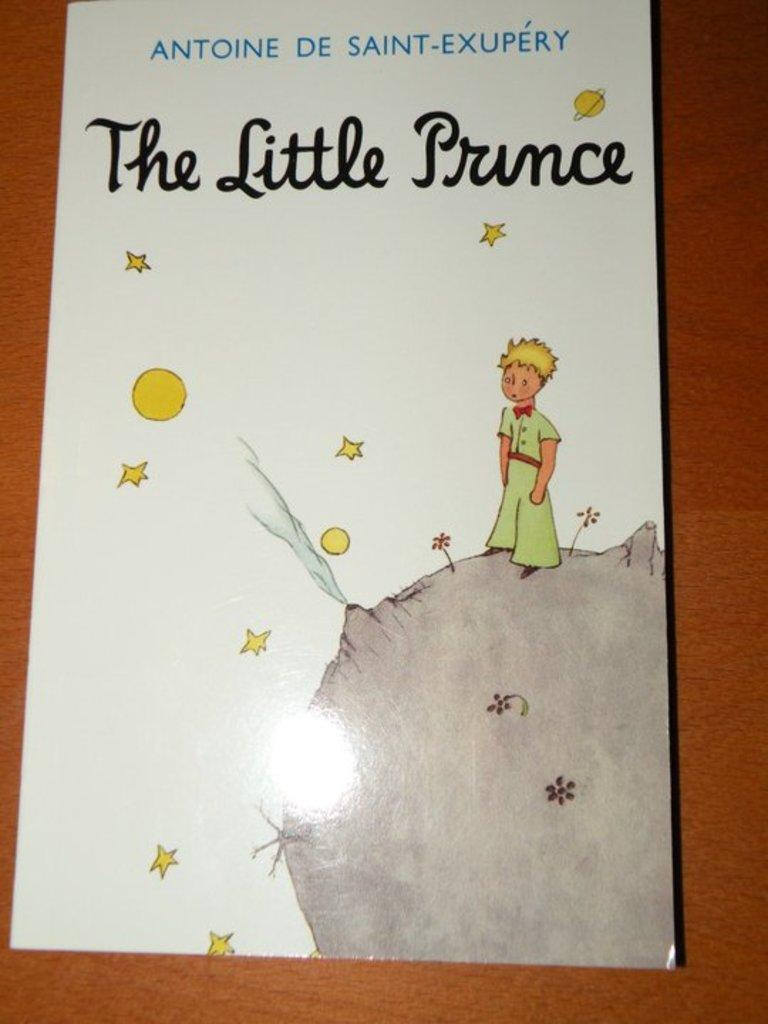Provide a one-sentence caption for the provided image. A children's book called The Little Prince is on a wooden table. 